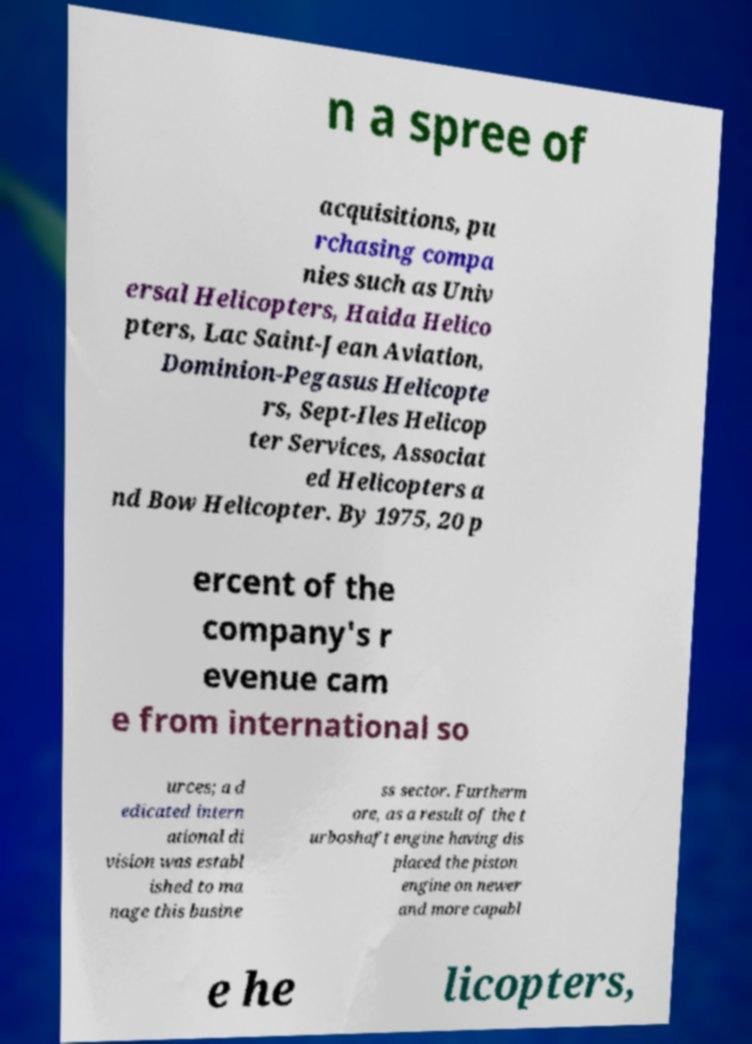For documentation purposes, I need the text within this image transcribed. Could you provide that? n a spree of acquisitions, pu rchasing compa nies such as Univ ersal Helicopters, Haida Helico pters, Lac Saint-Jean Aviation, Dominion-Pegasus Helicopte rs, Sept-Iles Helicop ter Services, Associat ed Helicopters a nd Bow Helicopter. By 1975, 20 p ercent of the company's r evenue cam e from international so urces; a d edicated intern ational di vision was establ ished to ma nage this busine ss sector. Furtherm ore, as a result of the t urboshaft engine having dis placed the piston engine on newer and more capabl e he licopters, 